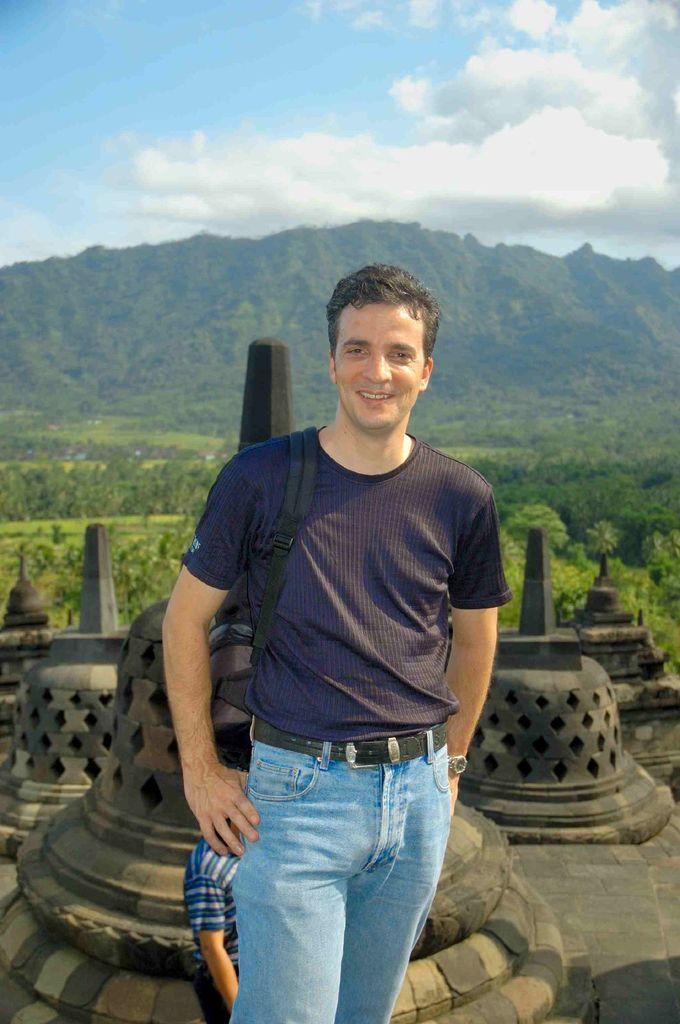Describe this image in one or two sentences. This image consists of a man wearing a blue T-shirt and blue jeans. In the background, there is a mountain along with plants and trees. At the top, there are clouds in the sky. 